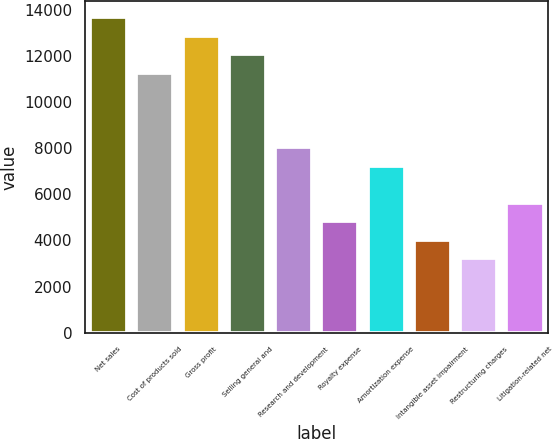<chart> <loc_0><loc_0><loc_500><loc_500><bar_chart><fcel>Net sales<fcel>Cost of products sold<fcel>Gross profit<fcel>Selling general and<fcel>Research and development<fcel>Royalty expense<fcel>Amortization expense<fcel>Intangible asset impairment<fcel>Restructuring charges<fcel>Litigation-related net<nl><fcel>13684<fcel>11269.4<fcel>12879.1<fcel>12074.3<fcel>8049.96<fcel>4830.52<fcel>7245.1<fcel>4025.66<fcel>3220.8<fcel>5635.38<nl></chart> 